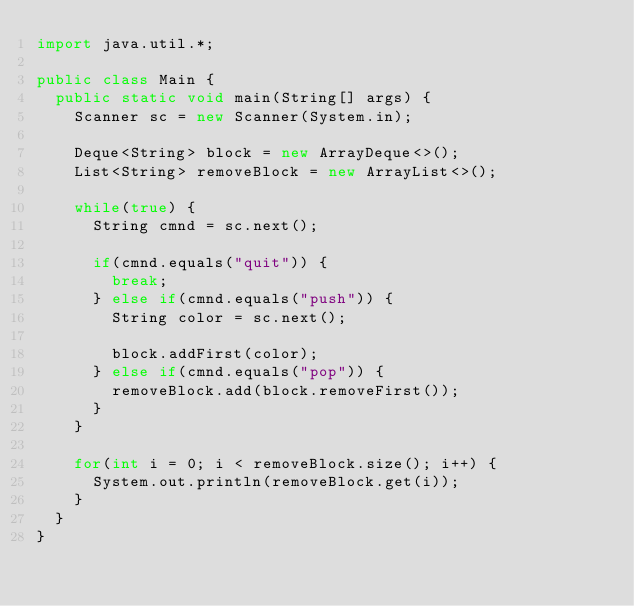<code> <loc_0><loc_0><loc_500><loc_500><_Java_>import java.util.*;

public class Main {
	public static void main(String[] args) {
		Scanner sc = new Scanner(System.in);
		
		Deque<String> block = new ArrayDeque<>();
		List<String> removeBlock = new ArrayList<>();
		
		while(true) {
			String cmnd = sc.next();
			
			if(cmnd.equals("quit")) {
				break;
			} else if(cmnd.equals("push")) {
				String color = sc.next();
				
				block.addFirst(color);
			} else if(cmnd.equals("pop")) {
				removeBlock.add(block.removeFirst());
			}
		}
		
		for(int i = 0; i < removeBlock.size(); i++) {
			System.out.println(removeBlock.get(i));
		}
	}
}</code> 